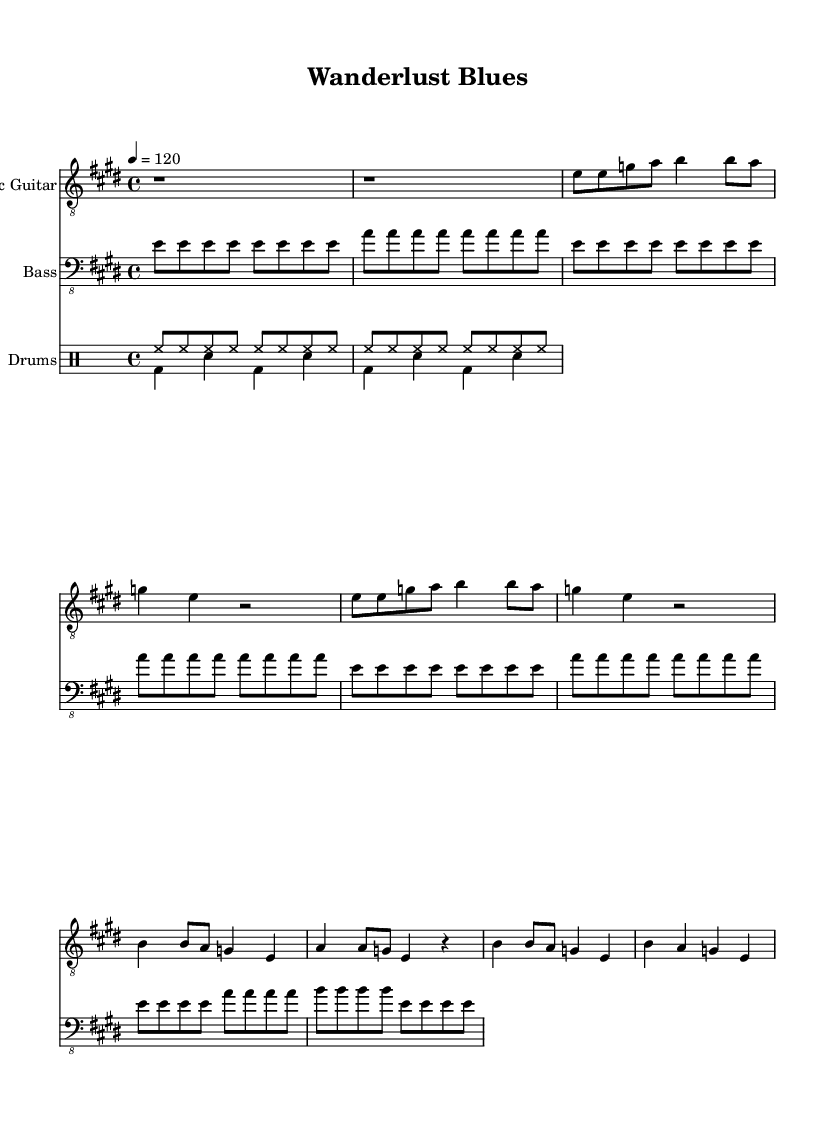What is the key signature of this music? The key signature is E major, which has four sharps (F#, C#, G#, D#). This can be identified at the beginning of the score where the key signature is notated.
Answer: E major What is the time signature of this music? The time signature is 4/4, indicated at the start of the score. This means there are four beats in a measure, and a quarter note receives one beat.
Answer: 4/4 What is the tempo marking for this music? The tempo marking is 120 beats per minute, written as "4 = 120". This indicates the pace at which the piece should be played.
Answer: 120 How many measures are in the verse section? The verse section consists of 4 measures. By analyzing the notes in the verse section, we can count the number of measures in that part.
Answer: 4 What instruments are included in this piece? The instruments are Electric Guitar, Bass, and Drums, as listed at the beginning of each staff in the score layout.
Answer: Electric Guitar, Bass, Drums What is the primary rhythmic pattern used by the drums? The primary rhythmic pattern consists of eighth notes on the hi-hat and a bass drum on beats 1 and 3. This is typical in blues to create a steady groove.
Answer: Eighth notes on hi-hat Which section starts with a rest? The piece begins with a rest in the Electric Guitar part. This rest serves as an introductory pause before the music starts, which is a common feature in blues to build anticipation.
Answer: Intro 